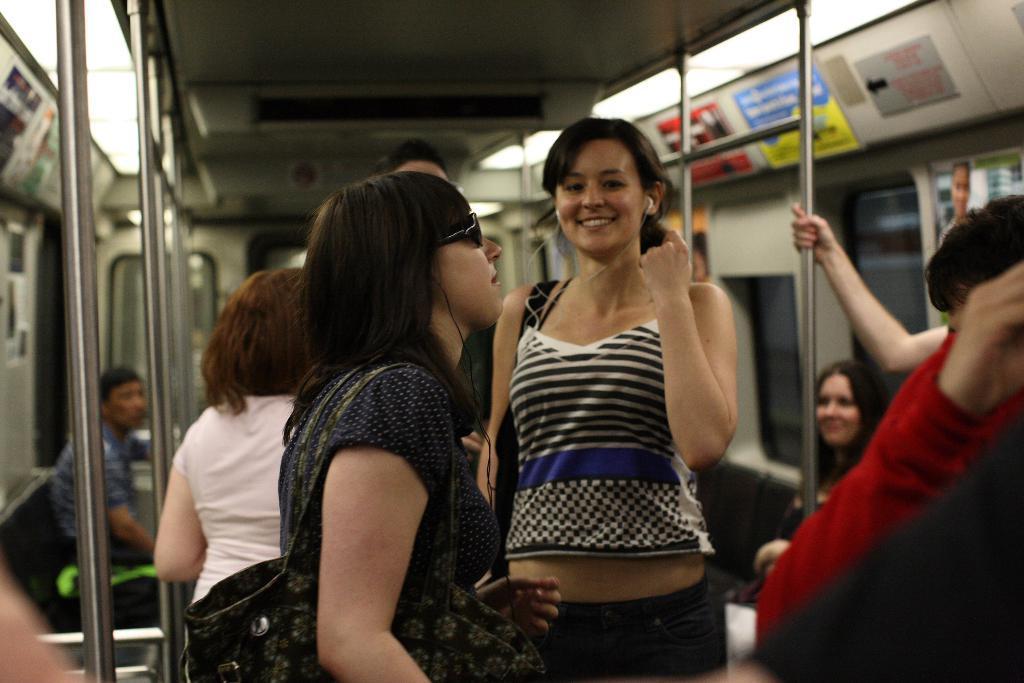Please provide a concise description of this image. This is the inside picture of the train. In this image there are a few people standing and there are a few people sitting on the chairs. There are metal poles. In the background of the image there are glass windows. There are posters on the wall. On top of the image there are lights. 